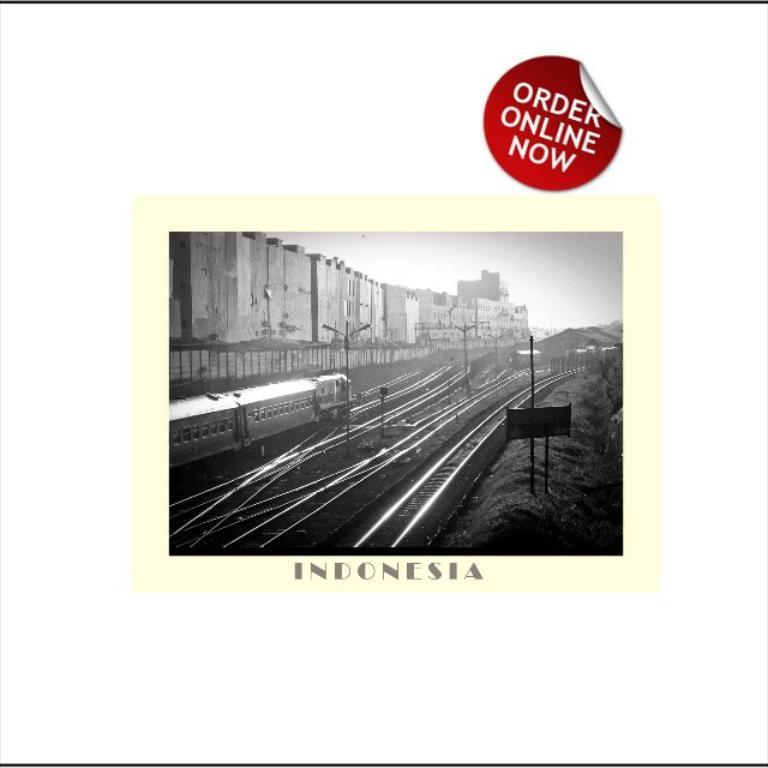Can you describe this image briefly? In the image we can see the poster, in the poster we can see black and white picture of the train on the train track. Here we can see buildings, text and the sky. 